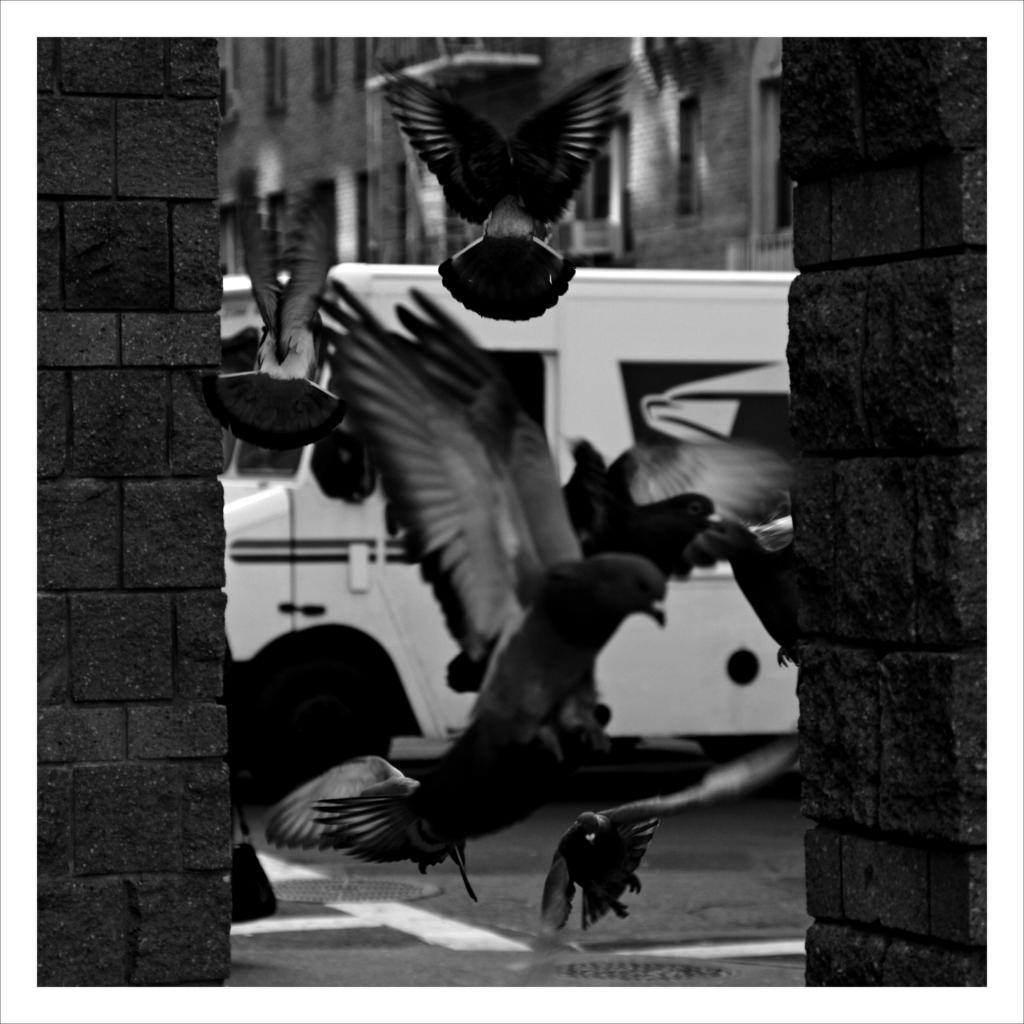What is the color scheme of the image? The image is black and white. What is happening in the sky in the image? There are birds flying in the image. What type of structures can be seen in the image? There are pillar-like structures in the image. What type of vehicle is parked in the image? There is a van parked in the image. What can be seen in the distance in the image? There is a building visible in the background of the image. Who is the owner of the cows in the image? There are no cows present in the image. What items are on the list in the image? There is no list present in the image. 